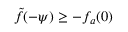<formula> <loc_0><loc_0><loc_500><loc_500>\tilde { f } ( - \psi ) \geq - f _ { a } ( 0 )</formula> 